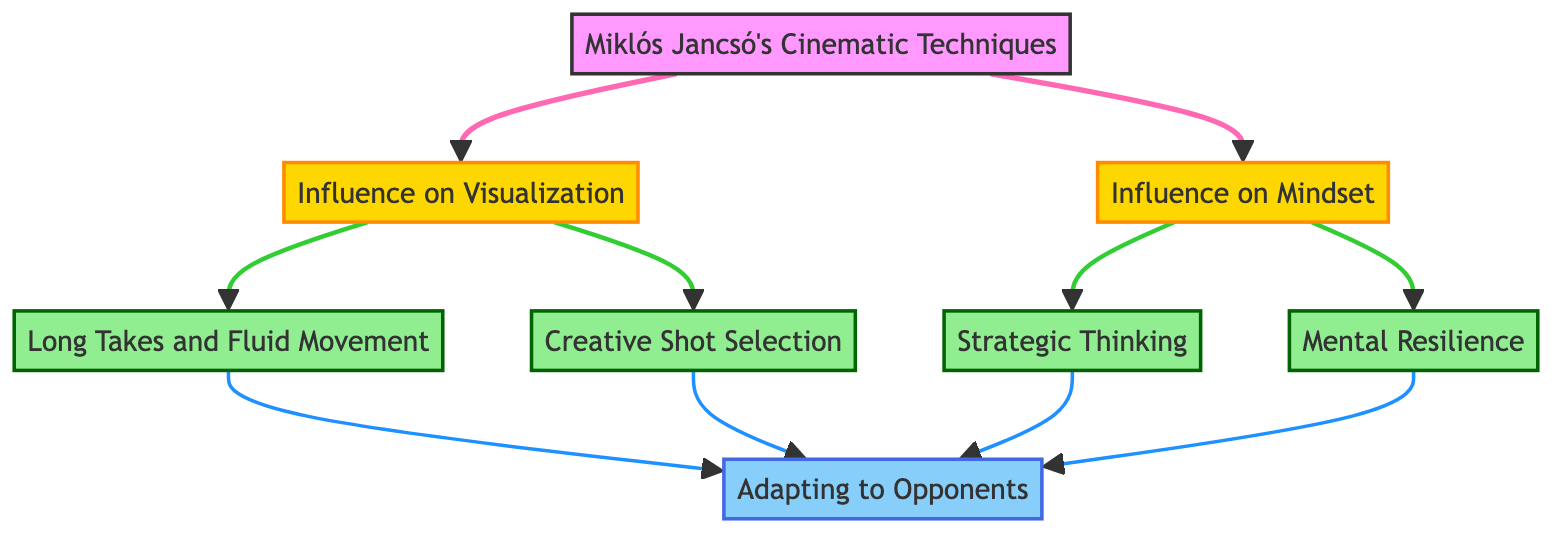What is Miklós Jancsó's main influence in the diagram? Jancsó's cinematic techniques influence both visualization and mindset, as shown by the two directed edges leading from Jancsó's techniques to these nodes.
Answer: Visualization and Mindset How many nodes are in the diagram? The diagram includes eight distinct nodes, each representing a different concept related to Jancsó's influence on playing style and techniques.
Answer: Eight Which technique is influenced by visualization? The directed edges from the "Influence on Visualization" node lead to both "Long Takes and Fluid Movement" and "Creative Shot Selection," indicating these techniques are influenced by visualization.
Answer: Long Takes and Fluid Movement, Creative Shot Selection What is the outcome of long takes and fluid movement? Following the directed edge, "Long Takes and Fluid Movement" leads to "Adapting to Opponents," meaning this technique assists in adapting to different opponents.
Answer: Adapting to Opponents Which two nodes connect to Mental Resilience? The "Influence on Mindset" node connects to "Mental Resilience" along with the "Strategic Thinking" node. This means both these aspects contribute to developing mental resilience.
Answer: Influence on Mindset, Strategic Thinking How many techniques influence the ability to adapt to opponents? By observing the directed edges, we can identify that there are four techniques that lead to "Adapting to Opponents": "Long Takes and Fluid Movement," "Creative Shot Selection," "Strategic Thinking," and "Mental Resilience."
Answer: Four What type of influence does Jancsó have over players' creativity in shot selection? Jancsó's cinematic techniques have a direct influence on "Creative Shot Selection," reflected by the arrow connecting "Miklós Jancsó's Cinematic Techniques" to this node.
Answer: Direct Influence Which two aspects are integral to developing Strategic Thinking? The "Influence on Mindset" node directly influences "Strategic Thinking," and both connect through their directed edges, showcasing the necessary mindset qualities for strategic development.
Answer: Influence on Mindset, Mental Resilience 